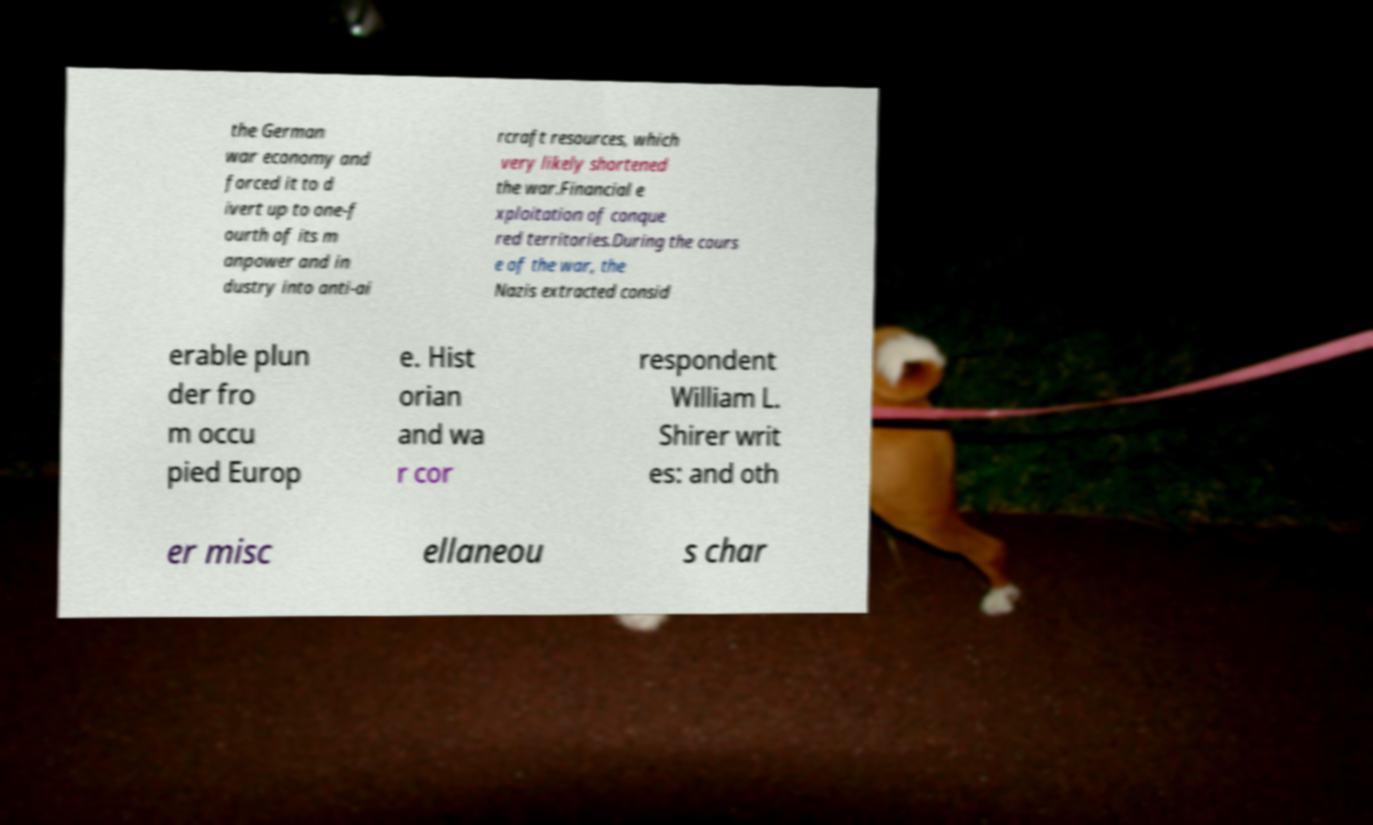Please identify and transcribe the text found in this image. the German war economy and forced it to d ivert up to one-f ourth of its m anpower and in dustry into anti-ai rcraft resources, which very likely shortened the war.Financial e xploitation of conque red territories.During the cours e of the war, the Nazis extracted consid erable plun der fro m occu pied Europ e. Hist orian and wa r cor respondent William L. Shirer writ es: and oth er misc ellaneou s char 